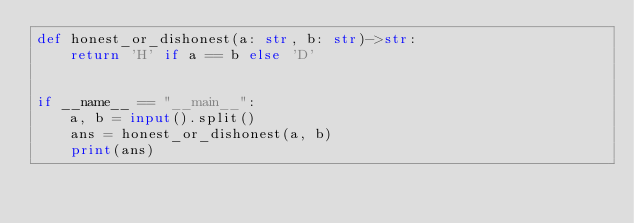<code> <loc_0><loc_0><loc_500><loc_500><_Python_>def honest_or_dishonest(a: str, b: str)->str:
    return 'H' if a == b else 'D'


if __name__ == "__main__":
    a, b = input().split()
    ans = honest_or_dishonest(a, b)
    print(ans)
</code> 